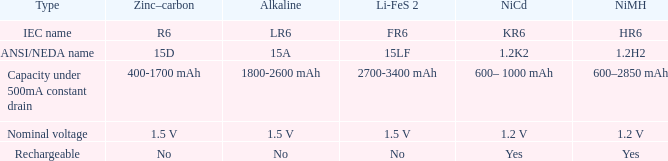What is Li-FeS 2, when Type is Nominal Voltage? 1.5 V. 